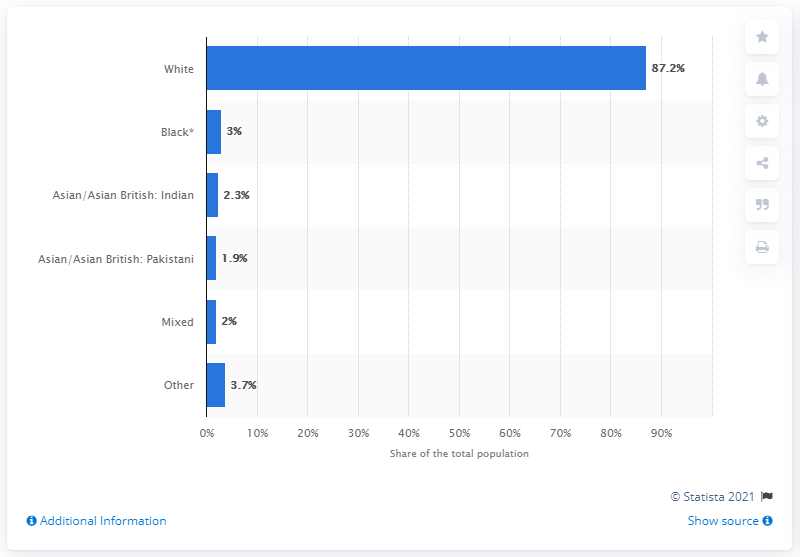Point out several critical features in this image. In 2011, 87.2% of the population of the UK was white. 